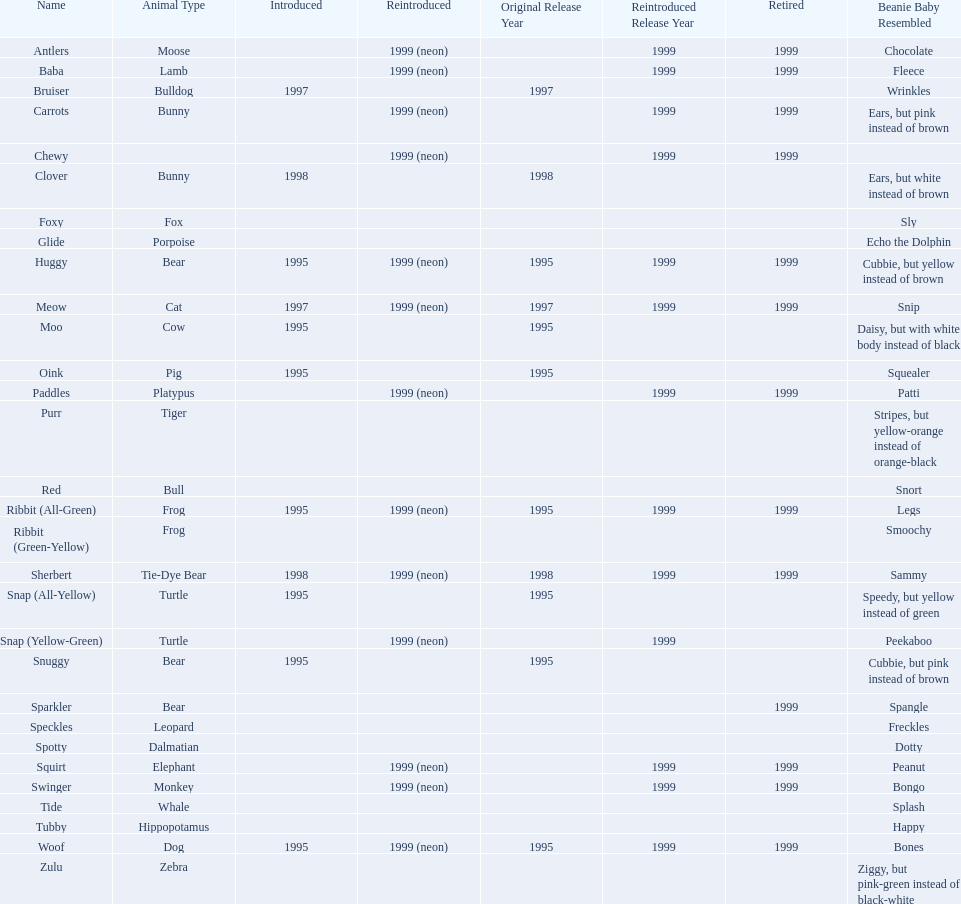What are all the different names of the pillow pals? Antlers, Baba, Bruiser, Carrots, Chewy, Clover, Foxy, Glide, Huggy, Meow, Moo, Oink, Paddles, Purr, Red, Ribbit (All-Green), Ribbit (Green-Yellow), Sherbert, Snap (All-Yellow), Snap (Yellow-Green), Snuggy, Sparkler, Speckles, Spotty, Squirt, Swinger, Tide, Tubby, Woof, Zulu. Which of these are a dalmatian? Spotty. 